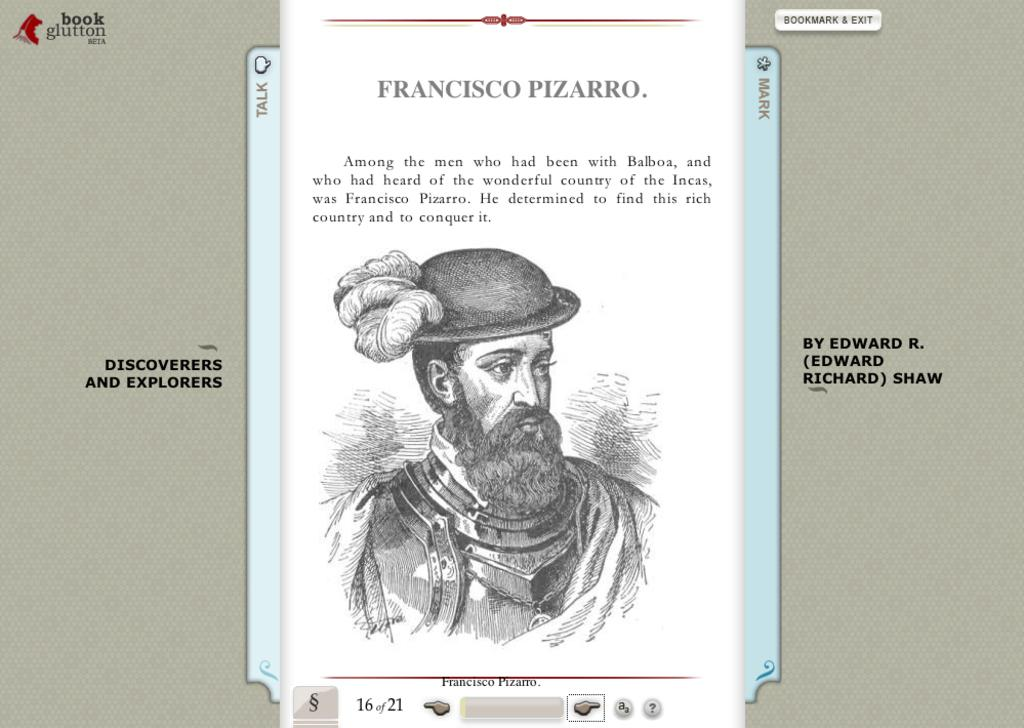What is the main subject of the image? The main subject of the image is a screen. What is displayed on the screen? There is a paper displayed on the screen. What can be seen on the paper? The paper has a picture of a person and text written on it. What type of yarn is being used to create the elbow in the image? There is no yarn or elbow present in the image; it features a screen displaying a paper with a picture of a person and text. 